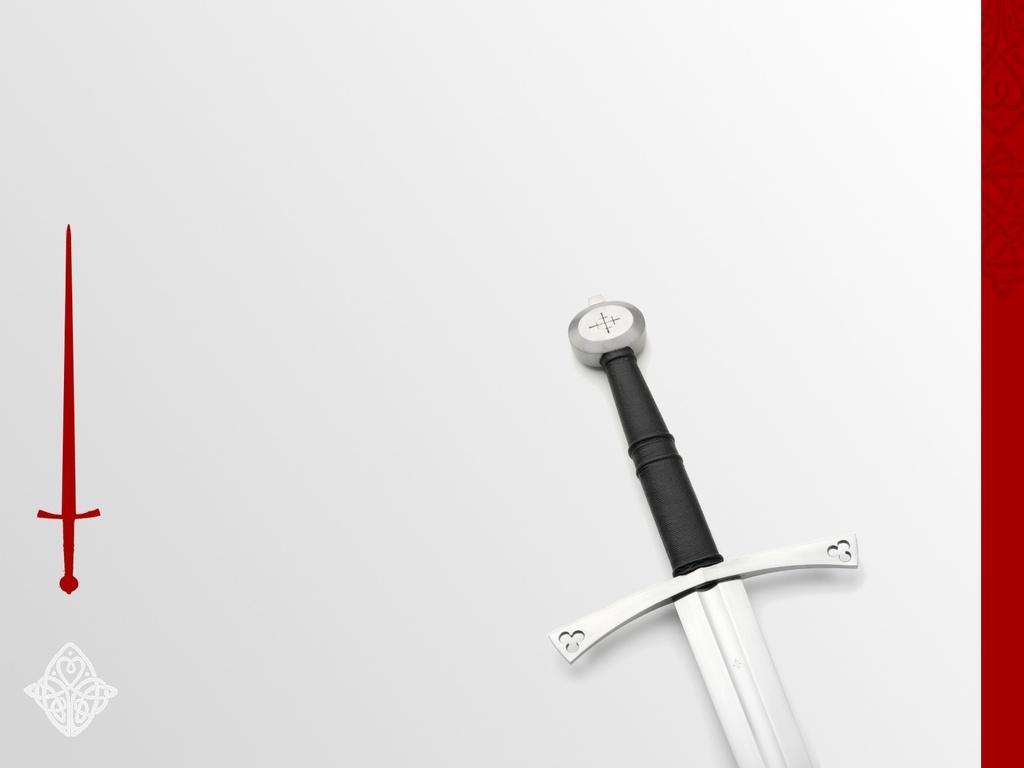Please provide a concise description of this image. There is a sword on a surface. There is a painting of a red sword at the left. 